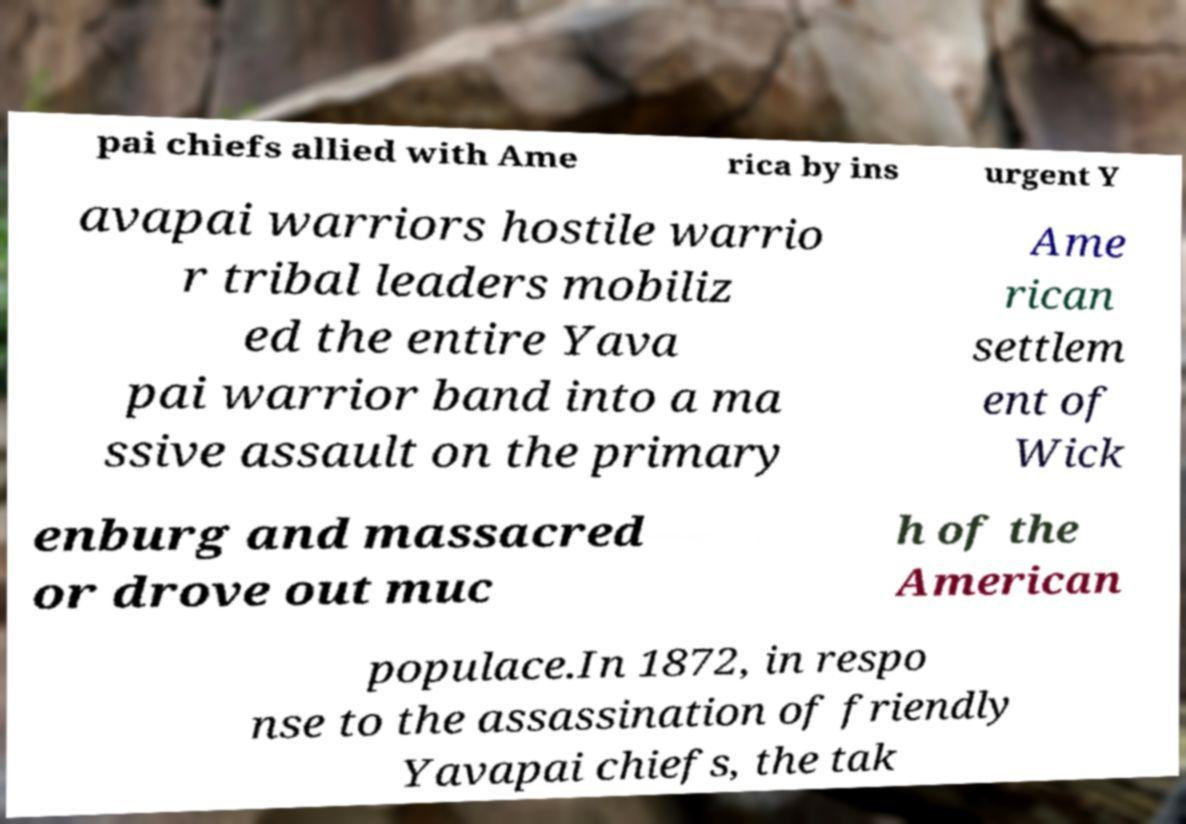Could you extract and type out the text from this image? pai chiefs allied with Ame rica by ins urgent Y avapai warriors hostile warrio r tribal leaders mobiliz ed the entire Yava pai warrior band into a ma ssive assault on the primary Ame rican settlem ent of Wick enburg and massacred or drove out muc h of the American populace.In 1872, in respo nse to the assassination of friendly Yavapai chiefs, the tak 